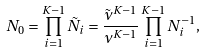<formula> <loc_0><loc_0><loc_500><loc_500>N _ { 0 } = \prod _ { i = 1 } ^ { K - 1 } \tilde { N } _ { i } = \frac { \tilde { \nu } ^ { K - 1 } } { \nu ^ { K - 1 } } \prod _ { i = 1 } ^ { K - 1 } N _ { i } ^ { - 1 } ,</formula> 